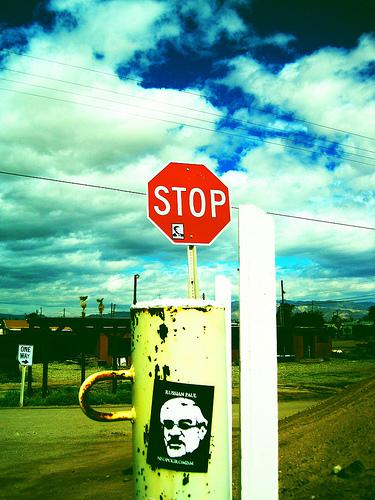Question: why is part of the yellow post brown?
Choices:
A. It was repainted.
B. Its wood and the yellow paint is chipping off.
C. It is rusted.
D. It was dirty.
Answer with the letter. Answer: C Question: where are there patches of blue?
Choices:
A. On the lake.
B. In the ocean.
C. In the sky.
D. In the pond.
Answer with the letter. Answer: C Question: what does the white sign say?
Choices:
A. No left turn.
B. One way.
C. Stay out.
D. Do not enter.
Answer with the letter. Answer: B 